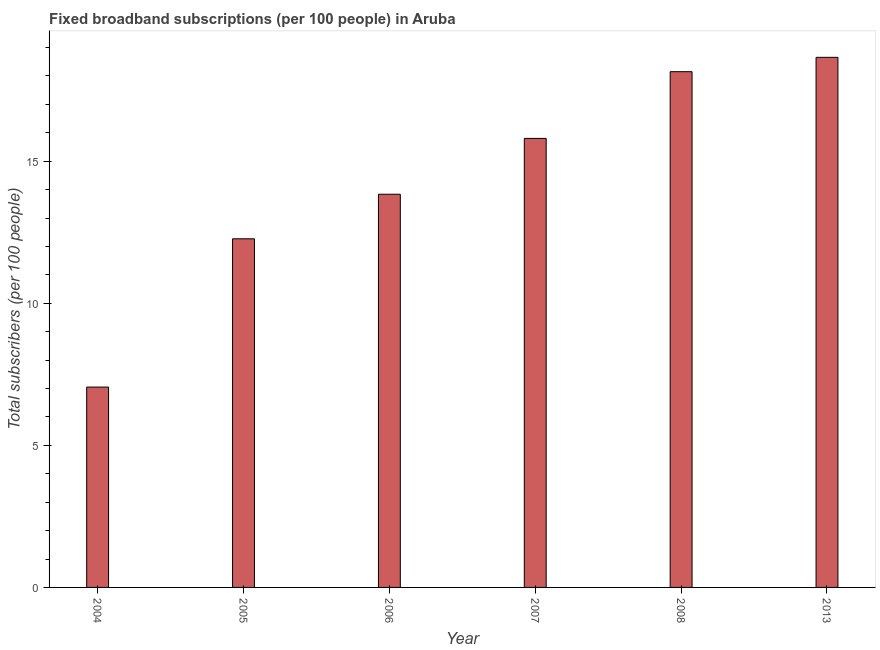What is the title of the graph?
Give a very brief answer. Fixed broadband subscriptions (per 100 people) in Aruba. What is the label or title of the X-axis?
Your answer should be compact. Year. What is the label or title of the Y-axis?
Ensure brevity in your answer.  Total subscribers (per 100 people). What is the total number of fixed broadband subscriptions in 2008?
Ensure brevity in your answer.  18.15. Across all years, what is the maximum total number of fixed broadband subscriptions?
Your answer should be compact. 18.66. Across all years, what is the minimum total number of fixed broadband subscriptions?
Offer a very short reply. 7.05. In which year was the total number of fixed broadband subscriptions maximum?
Your answer should be compact. 2013. In which year was the total number of fixed broadband subscriptions minimum?
Your answer should be compact. 2004. What is the sum of the total number of fixed broadband subscriptions?
Offer a very short reply. 85.77. What is the difference between the total number of fixed broadband subscriptions in 2007 and 2013?
Keep it short and to the point. -2.85. What is the average total number of fixed broadband subscriptions per year?
Your answer should be very brief. 14.29. What is the median total number of fixed broadband subscriptions?
Keep it short and to the point. 14.82. Do a majority of the years between 2008 and 2006 (inclusive) have total number of fixed broadband subscriptions greater than 2 ?
Offer a terse response. Yes. What is the ratio of the total number of fixed broadband subscriptions in 2006 to that in 2013?
Make the answer very short. 0.74. Is the difference between the total number of fixed broadband subscriptions in 2006 and 2008 greater than the difference between any two years?
Give a very brief answer. No. What is the difference between the highest and the second highest total number of fixed broadband subscriptions?
Your answer should be compact. 0.51. What is the difference between the highest and the lowest total number of fixed broadband subscriptions?
Make the answer very short. 11.61. In how many years, is the total number of fixed broadband subscriptions greater than the average total number of fixed broadband subscriptions taken over all years?
Provide a short and direct response. 3. How many bars are there?
Provide a short and direct response. 6. Are all the bars in the graph horizontal?
Offer a very short reply. No. How many years are there in the graph?
Provide a short and direct response. 6. What is the difference between two consecutive major ticks on the Y-axis?
Your response must be concise. 5. What is the Total subscribers (per 100 people) of 2004?
Your response must be concise. 7.05. What is the Total subscribers (per 100 people) of 2005?
Give a very brief answer. 12.27. What is the Total subscribers (per 100 people) in 2006?
Your answer should be very brief. 13.84. What is the Total subscribers (per 100 people) in 2007?
Provide a succinct answer. 15.8. What is the Total subscribers (per 100 people) in 2008?
Make the answer very short. 18.15. What is the Total subscribers (per 100 people) in 2013?
Give a very brief answer. 18.66. What is the difference between the Total subscribers (per 100 people) in 2004 and 2005?
Offer a very short reply. -5.22. What is the difference between the Total subscribers (per 100 people) in 2004 and 2006?
Make the answer very short. -6.79. What is the difference between the Total subscribers (per 100 people) in 2004 and 2007?
Offer a very short reply. -8.75. What is the difference between the Total subscribers (per 100 people) in 2004 and 2008?
Make the answer very short. -11.1. What is the difference between the Total subscribers (per 100 people) in 2004 and 2013?
Make the answer very short. -11.61. What is the difference between the Total subscribers (per 100 people) in 2005 and 2006?
Make the answer very short. -1.57. What is the difference between the Total subscribers (per 100 people) in 2005 and 2007?
Your answer should be very brief. -3.53. What is the difference between the Total subscribers (per 100 people) in 2005 and 2008?
Provide a short and direct response. -5.88. What is the difference between the Total subscribers (per 100 people) in 2005 and 2013?
Provide a short and direct response. -6.39. What is the difference between the Total subscribers (per 100 people) in 2006 and 2007?
Keep it short and to the point. -1.97. What is the difference between the Total subscribers (per 100 people) in 2006 and 2008?
Give a very brief answer. -4.31. What is the difference between the Total subscribers (per 100 people) in 2006 and 2013?
Provide a short and direct response. -4.82. What is the difference between the Total subscribers (per 100 people) in 2007 and 2008?
Make the answer very short. -2.35. What is the difference between the Total subscribers (per 100 people) in 2007 and 2013?
Provide a succinct answer. -2.85. What is the difference between the Total subscribers (per 100 people) in 2008 and 2013?
Offer a terse response. -0.5. What is the ratio of the Total subscribers (per 100 people) in 2004 to that in 2005?
Make the answer very short. 0.57. What is the ratio of the Total subscribers (per 100 people) in 2004 to that in 2006?
Make the answer very short. 0.51. What is the ratio of the Total subscribers (per 100 people) in 2004 to that in 2007?
Offer a very short reply. 0.45. What is the ratio of the Total subscribers (per 100 people) in 2004 to that in 2008?
Keep it short and to the point. 0.39. What is the ratio of the Total subscribers (per 100 people) in 2004 to that in 2013?
Your response must be concise. 0.38. What is the ratio of the Total subscribers (per 100 people) in 2005 to that in 2006?
Keep it short and to the point. 0.89. What is the ratio of the Total subscribers (per 100 people) in 2005 to that in 2007?
Offer a terse response. 0.78. What is the ratio of the Total subscribers (per 100 people) in 2005 to that in 2008?
Provide a succinct answer. 0.68. What is the ratio of the Total subscribers (per 100 people) in 2005 to that in 2013?
Keep it short and to the point. 0.66. What is the ratio of the Total subscribers (per 100 people) in 2006 to that in 2007?
Ensure brevity in your answer.  0.88. What is the ratio of the Total subscribers (per 100 people) in 2006 to that in 2008?
Provide a succinct answer. 0.76. What is the ratio of the Total subscribers (per 100 people) in 2006 to that in 2013?
Make the answer very short. 0.74. What is the ratio of the Total subscribers (per 100 people) in 2007 to that in 2008?
Offer a very short reply. 0.87. What is the ratio of the Total subscribers (per 100 people) in 2007 to that in 2013?
Make the answer very short. 0.85. 